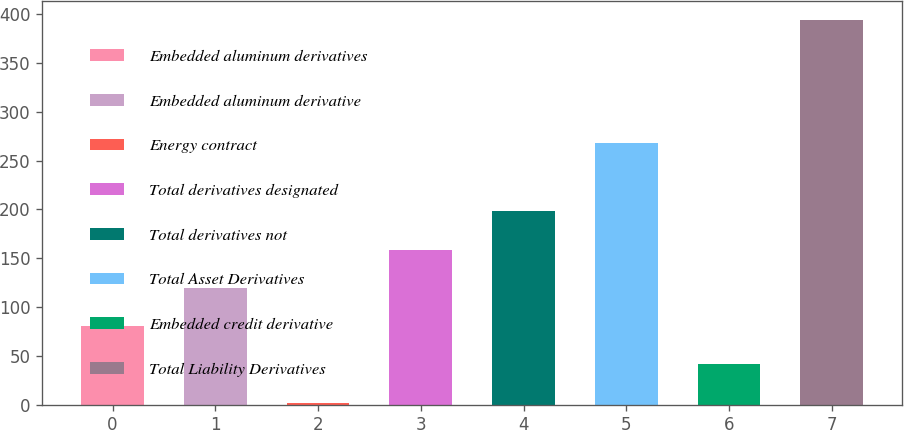Convert chart. <chart><loc_0><loc_0><loc_500><loc_500><bar_chart><fcel>Embedded aluminum derivatives<fcel>Embedded aluminum derivative<fcel>Energy contract<fcel>Total derivatives designated<fcel>Total derivatives not<fcel>Total Asset Derivatives<fcel>Embedded credit derivative<fcel>Total Liability Derivatives<nl><fcel>80.4<fcel>119.6<fcel>2<fcel>158.8<fcel>198<fcel>268<fcel>41.2<fcel>394<nl></chart> 